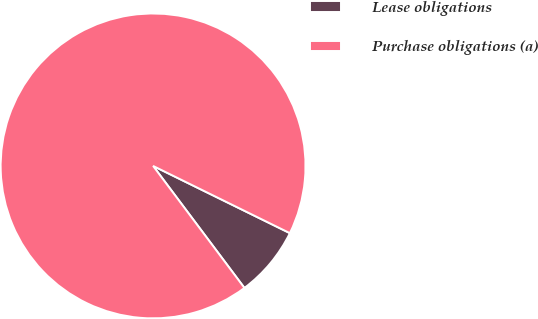Convert chart. <chart><loc_0><loc_0><loc_500><loc_500><pie_chart><fcel>Lease obligations<fcel>Purchase obligations (a)<nl><fcel>7.5%<fcel>92.5%<nl></chart> 